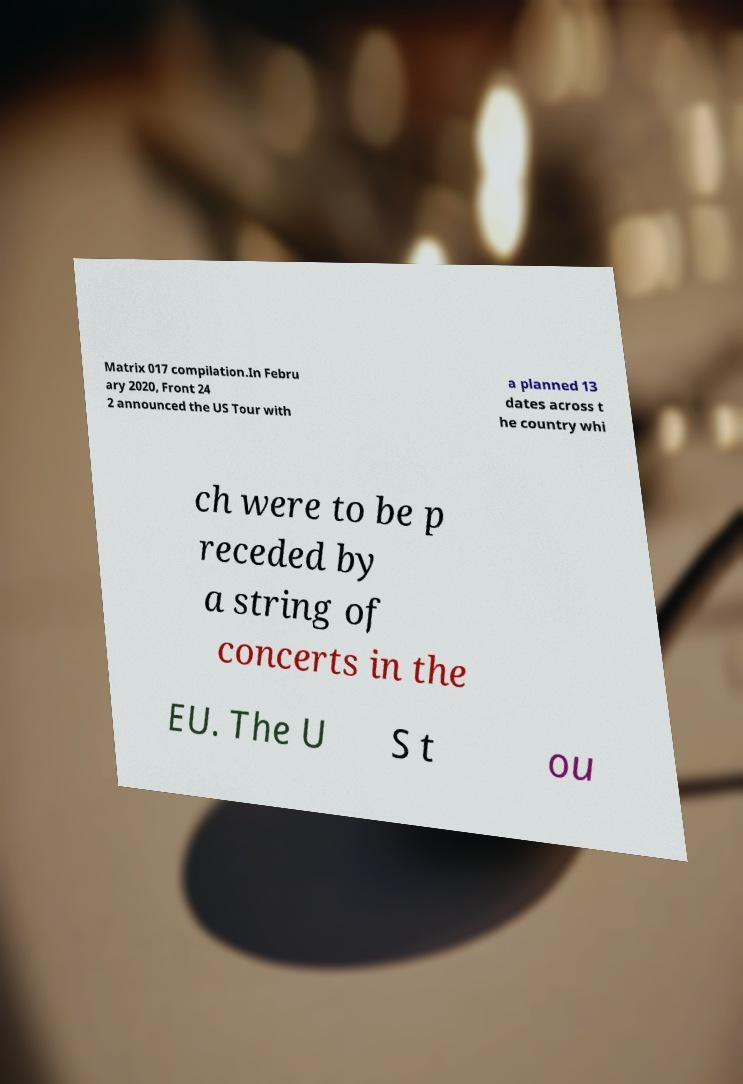Could you assist in decoding the text presented in this image and type it out clearly? Matrix 017 compilation.In Febru ary 2020, Front 24 2 announced the US Tour with a planned 13 dates across t he country whi ch were to be p receded by a string of concerts in the EU. The U S t ou 